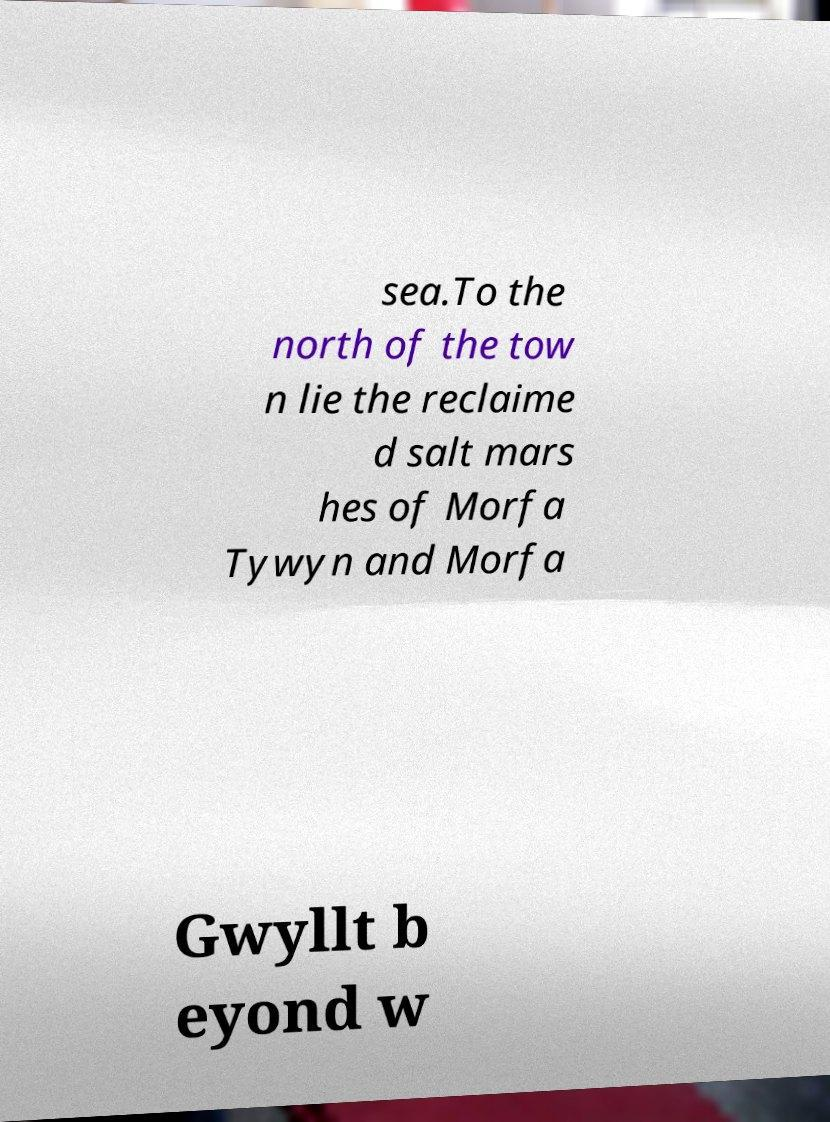Please read and relay the text visible in this image. What does it say? sea.To the north of the tow n lie the reclaime d salt mars hes of Morfa Tywyn and Morfa Gwyllt b eyond w 